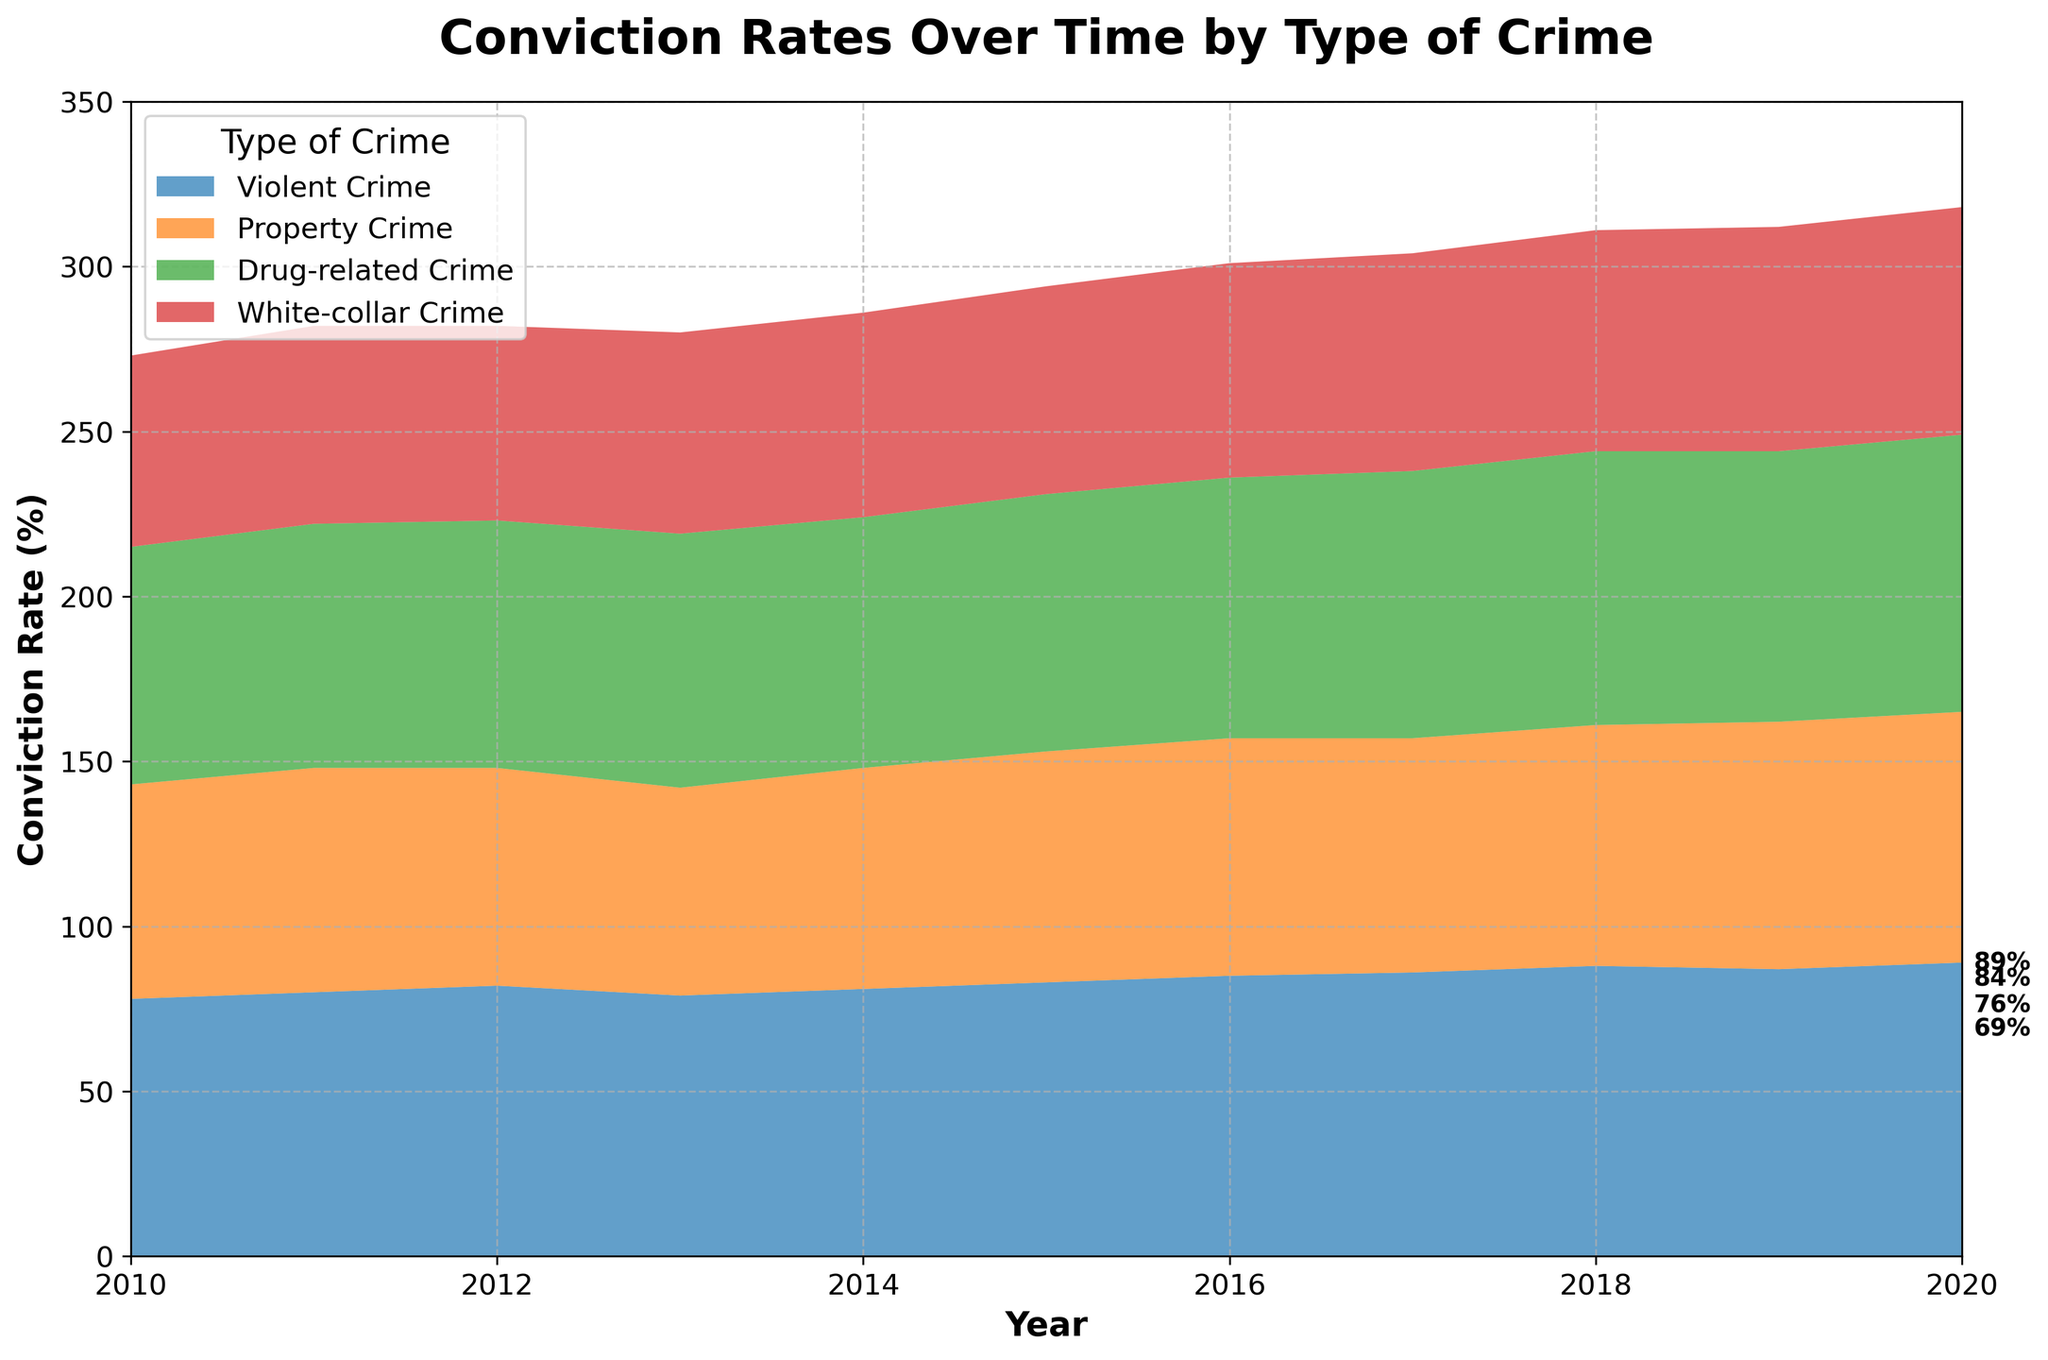What is the title of the figure? The title is usually located at the top center of the figure. It provides a summary of what the figure represents.
Answer: Conviction Rates Over Time by Type of Crime What are the two axes labeled, and what do they represent? The x-axis label is "Year" and it represents the time period from 2010 to 2020. The y-axis label is "Conviction Rate (%)" and it represents the percentage of conviction rates.
Answer: Year and Conviction Rate (%) Which type of crime had the highest conviction rate in 2020? By observing the stacked area chart at the point where the year is 2020, we can see which type of crime has the highest conviction rate by the value annotated.
Answer: Violent Crime How has the conviction rate for white-collar crimes changed from 2010 to 2020? To understand the change, we need to compare the conviction rate for white-collar crimes in 2010 and 2020 by looking at the corresponding annotations. In 2010, it is 58%, and in 2020, it is 69%.
Answer: Increased by 11% In which year did property crimes show the lowest conviction rate and what was it? We need to compare the areas representing property crimes over the years to find the year with the lowest level. The lowest value is observed in 2013 at 63%.
Answer: 2013 with 63% What is the combined conviction rate for all crime types in 2014? To find this, sum up the conviction rates of all crime types in 2014 by adding their corresponding values: Violent Crime (81) + Property Crime (67) + Drug-related Crime (76) + White-collar Crime (62).
Answer: 286% Which crime type showed the greatest increase in conviction rates between 2017 and 2020? Calculate the difference in conviction rates for each type of crime between 2017 and 2020, then identify the type with the greatest difference.
Answer: Drug-related Crime Compare the overall trend for violent and drug-related crimes' conviction rates from 2010 to 2020. By observing the graphs for violent crimes and drug-related crimes, we see if they are generally increasing, decreasing, or stable. Both show an increasing trend, but Drug-related Crime has a noticeable uptick around 2017-2020.
Answer: Both are increasing What type of crime had a close conviction rate to property crimes in 2016? By observing the areas at the point where the year is 2016, we notice which other type of crime has close values.
Answer: White-collar Crime Which type of crime never exceeded a 70% conviction rate from 2010 to 2020? To answer this, check each type of crime's line across all years and see if it ever stays below 70%.
Answer: White-collar Crime How did the combined conviction rate change from 2015 to 2016? The step-by-step calculation involves adding all crime type conviction rates for both years and then finding the difference: 2015 (83+70+78+63) and 2016 (85+72+79+65).
Answer: Increased by 10% 